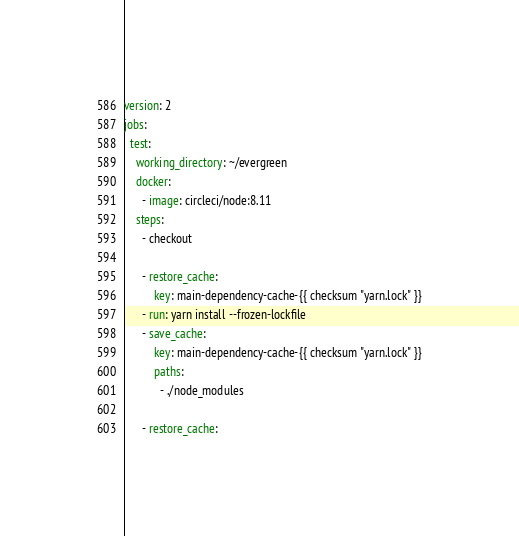<code> <loc_0><loc_0><loc_500><loc_500><_YAML_>version: 2
jobs:
  test:
    working_directory: ~/evergreen
    docker:
      - image: circleci/node:8.11
    steps:
      - checkout

      - restore_cache:
          key: main-dependency-cache-{{ checksum "yarn.lock" }}
      - run: yarn install --frozen-lockfile
      - save_cache:
          key: main-dependency-cache-{{ checksum "yarn.lock" }}
          paths:
            - ./node_modules

      - restore_cache:</code> 